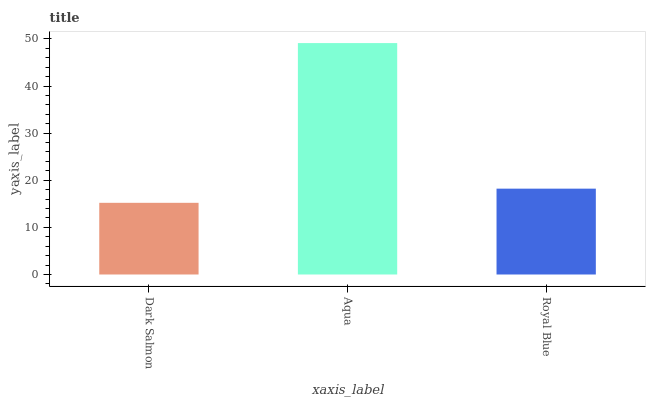Is Dark Salmon the minimum?
Answer yes or no. Yes. Is Aqua the maximum?
Answer yes or no. Yes. Is Royal Blue the minimum?
Answer yes or no. No. Is Royal Blue the maximum?
Answer yes or no. No. Is Aqua greater than Royal Blue?
Answer yes or no. Yes. Is Royal Blue less than Aqua?
Answer yes or no. Yes. Is Royal Blue greater than Aqua?
Answer yes or no. No. Is Aqua less than Royal Blue?
Answer yes or no. No. Is Royal Blue the high median?
Answer yes or no. Yes. Is Royal Blue the low median?
Answer yes or no. Yes. Is Aqua the high median?
Answer yes or no. No. Is Dark Salmon the low median?
Answer yes or no. No. 